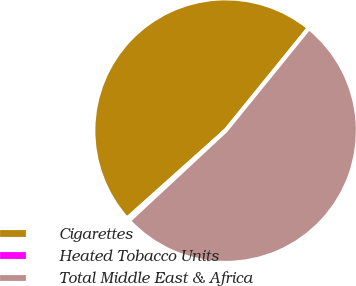<chart> <loc_0><loc_0><loc_500><loc_500><pie_chart><fcel>Cigarettes<fcel>Heated Tobacco Units<fcel>Total Middle East & Africa<nl><fcel>47.47%<fcel>0.31%<fcel>52.22%<nl></chart> 